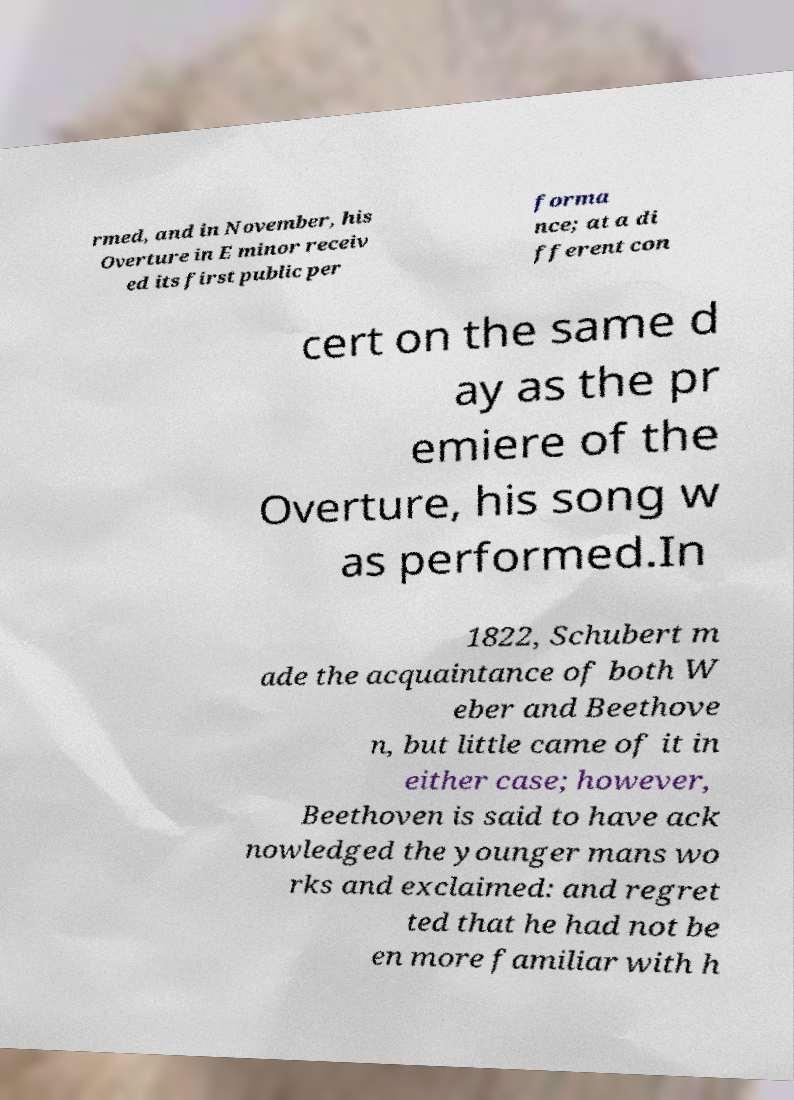Please read and relay the text visible in this image. What does it say? rmed, and in November, his Overture in E minor receiv ed its first public per forma nce; at a di fferent con cert on the same d ay as the pr emiere of the Overture, his song w as performed.In 1822, Schubert m ade the acquaintance of both W eber and Beethove n, but little came of it in either case; however, Beethoven is said to have ack nowledged the younger mans wo rks and exclaimed: and regret ted that he had not be en more familiar with h 